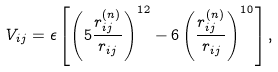<formula> <loc_0><loc_0><loc_500><loc_500>V _ { i j } = \epsilon \left [ \left ( 5 \frac { r ^ { ( n ) } _ { i j } } { r _ { i j } } \right ) ^ { 1 2 } - 6 \left ( \frac { r ^ { ( n ) } _ { i j } } { r _ { i j } } \right ) ^ { 1 0 } \right ] ,</formula> 